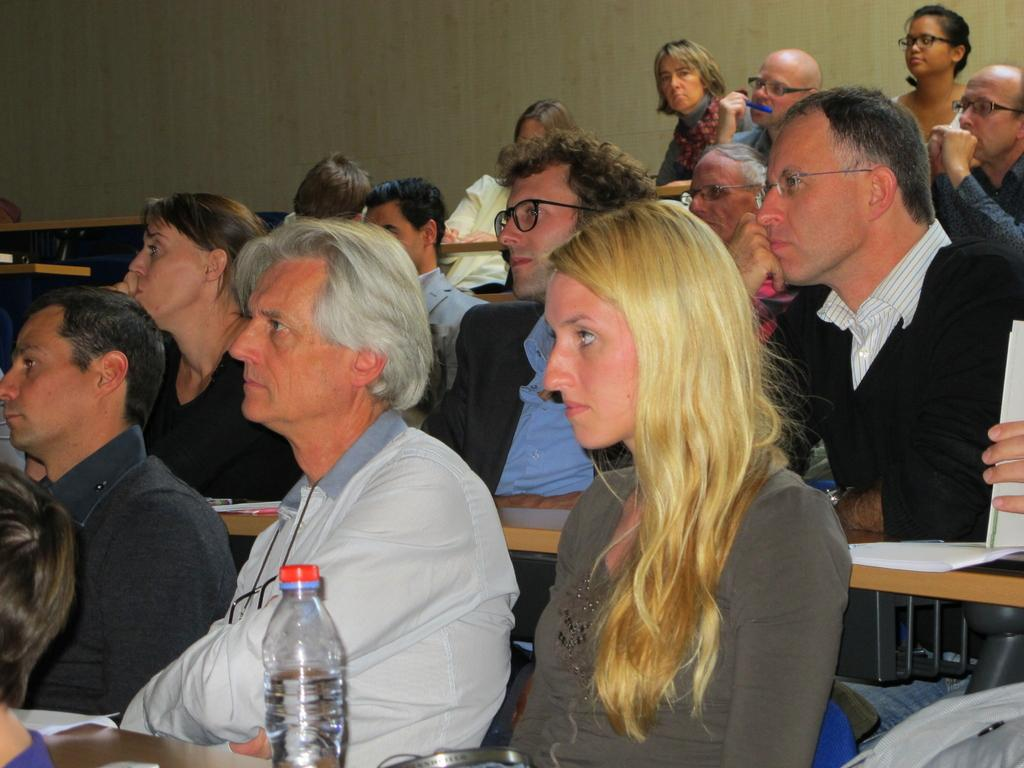What are the people in the image doing? The people in the image are sitting on chairs. What is in front of the chairs? There are benches in front of the chairs. What is placed on the benches? Papers, a bottle of water, and other objects are present on the benches. What can be seen behind the people? There is a wall visible behind the people. What type of silver quiver can be seen on the wall behind the people? There is no silver quiver present on the wall behind the people in the image. 